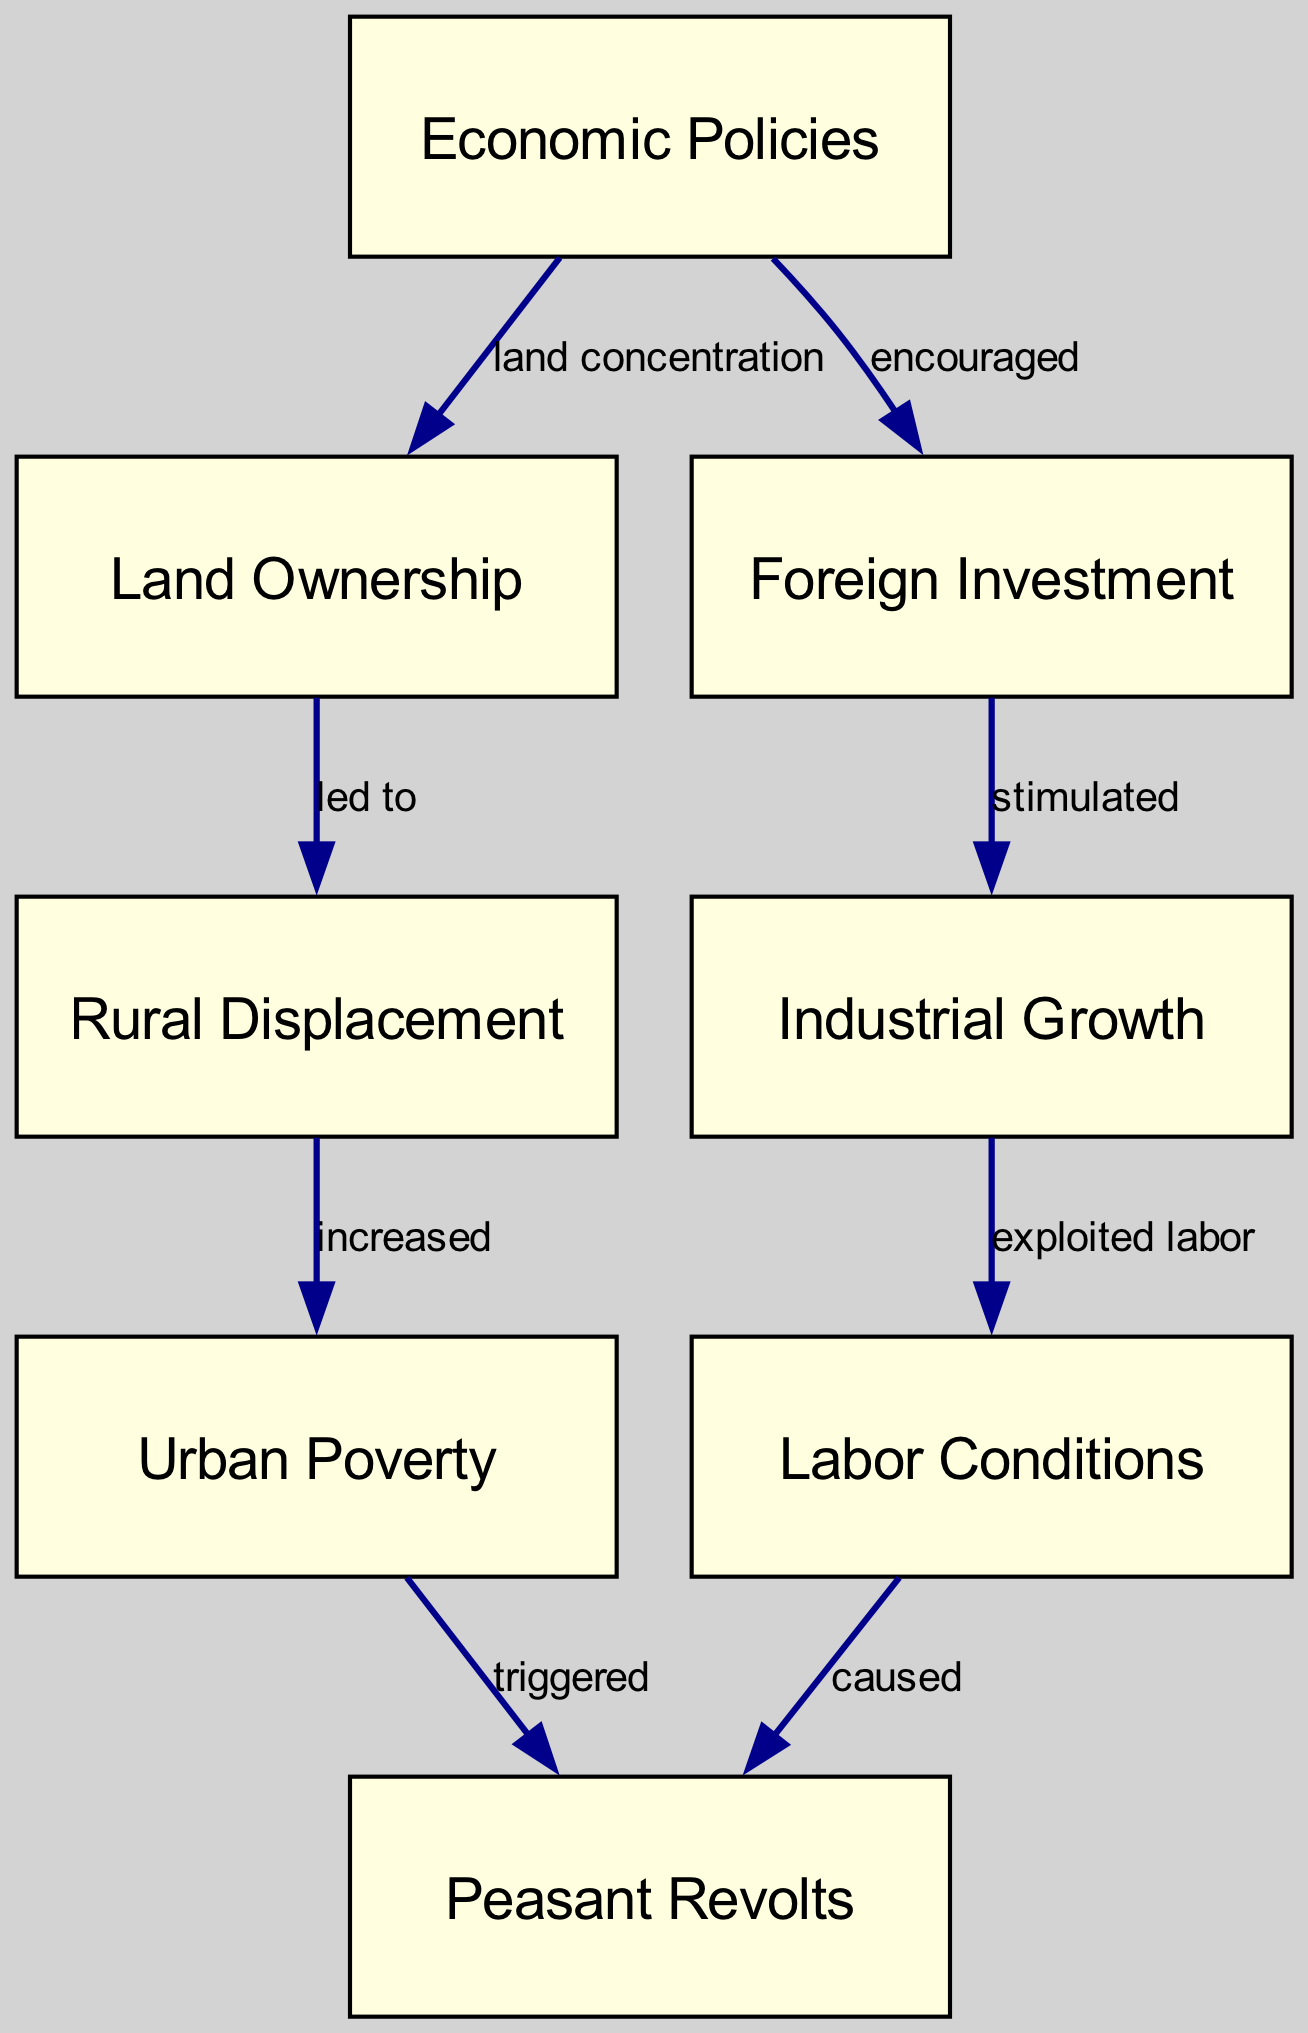What is the label of the first node? The first node in the diagram is labeled "Economic Policies." This is evident as it is the first entry in the node list.
Answer: Economic Policies How many edges are present in the diagram? By counting the connections listed in the edges section, there are a total of eight connections (edges) in the diagram.
Answer: 8 What relationship does "Economic Policies" have with "Foreign Investment"? The relationship is labeled "encouraged," indicating that economic policies fostered or supported foreign investment. This can be directly seen in the edge connecting these two nodes.
Answer: encouraged Which node is connected to "Labor Conditions" that indicates a cause-and-effect relationship? "Labor Conditions" is connected to "Peasant Revolts" with the label "caused," showing that labor conditions played a role in leading to peasant revolts. This relationship is drawn from the edge leading from labor conditions to peasant revolts.
Answer: caused What node follows "Industrial Growth" in a direct relationship? The node that follows "Industrial Growth" is "Labor Conditions," and the relationship is labeled "exploited labor." This indicates that industrial growth led to the exploitation of labor.
Answer: Labor Conditions How does "Rural Displacement" relate to "Urban Poverty"? "Rural Displacement" is connected to "Urban Poverty" with the label "increased," meaning that the process of rural displacement resulted in increased urban poverty. This can be seen as a direct impact in the diagram.
Answer: increased Identify the label of the node that is influenced by both "Land Ownership" and "Economic Policies." The node affected by both "Land Ownership" and "Economic Policies" is "Rural Displacement." The edge from land ownership indicates that concentration led to rural displacement, showing its dependency on previous nodes.
Answer: Rural Displacement What leads to "Peasant Revolts" based on the diagram? "Peasant Revolts" are triggered by "Urban Poverty," indicating that conditions of poverty in urban areas can lead to increased instances of revolts among peasants. This is visible through the edge connecting urban poverty to peasant revolts.
Answer: triggered What does "Foreign Investment" stimulate according to the diagram? "Foreign Investment" stimulates "Industrial Growth," showing a direct causal relationship where increased foreign investment leads to advancements in industry. This relationship is visible as an edge connecting these nodes.
Answer: Industrial Growth 